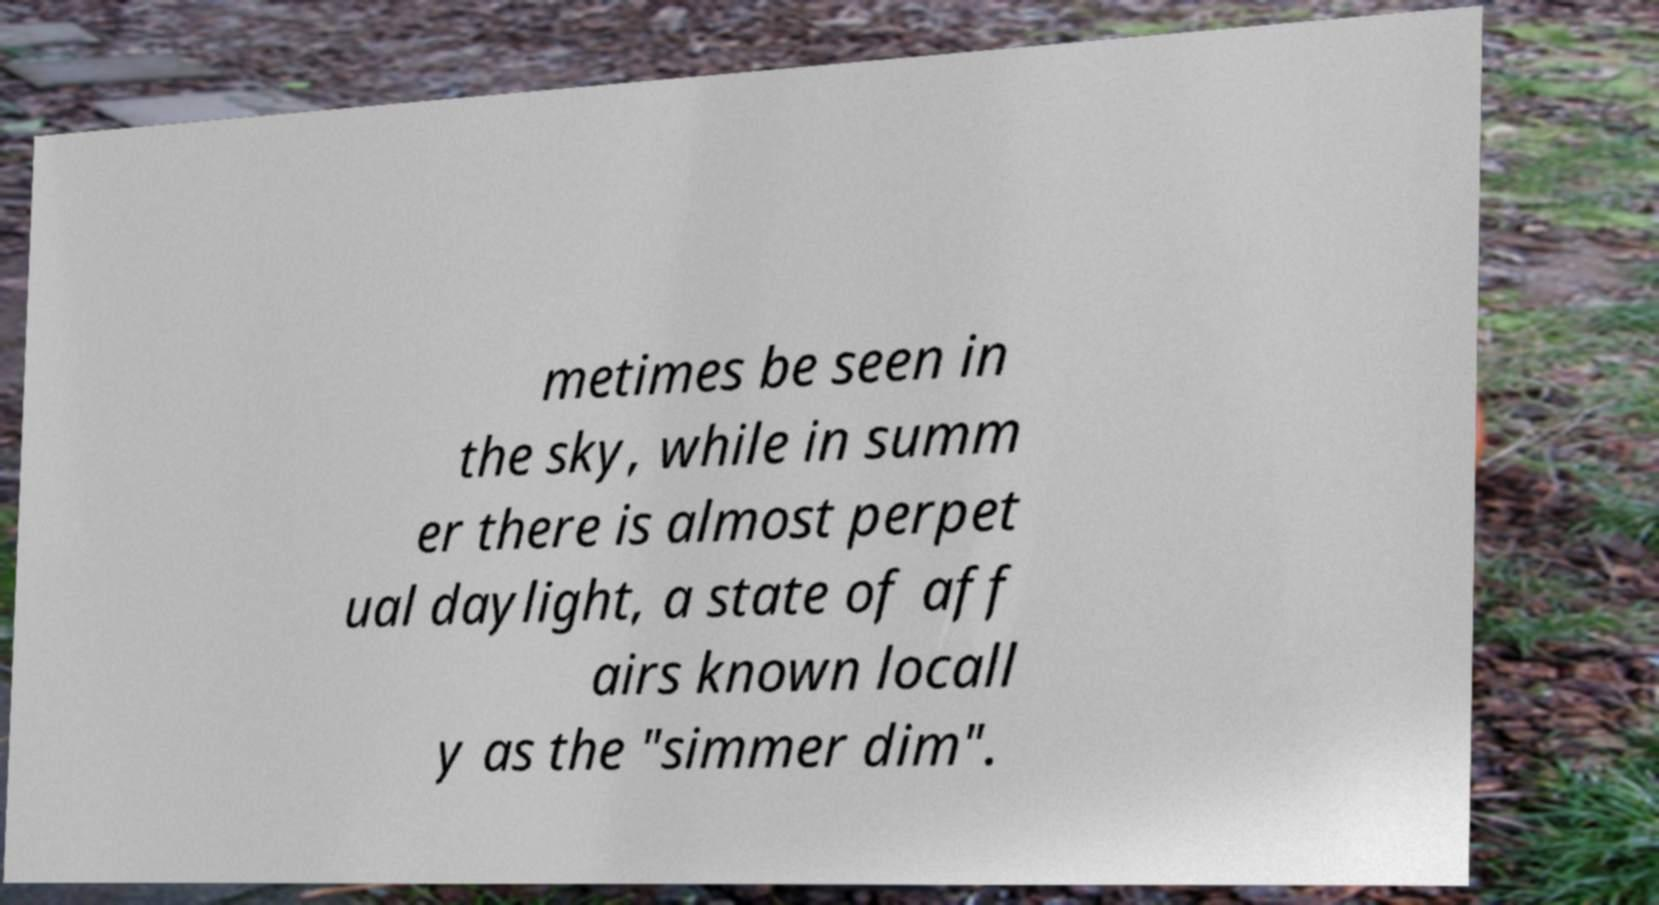For documentation purposes, I need the text within this image transcribed. Could you provide that? metimes be seen in the sky, while in summ er there is almost perpet ual daylight, a state of aff airs known locall y as the "simmer dim". 